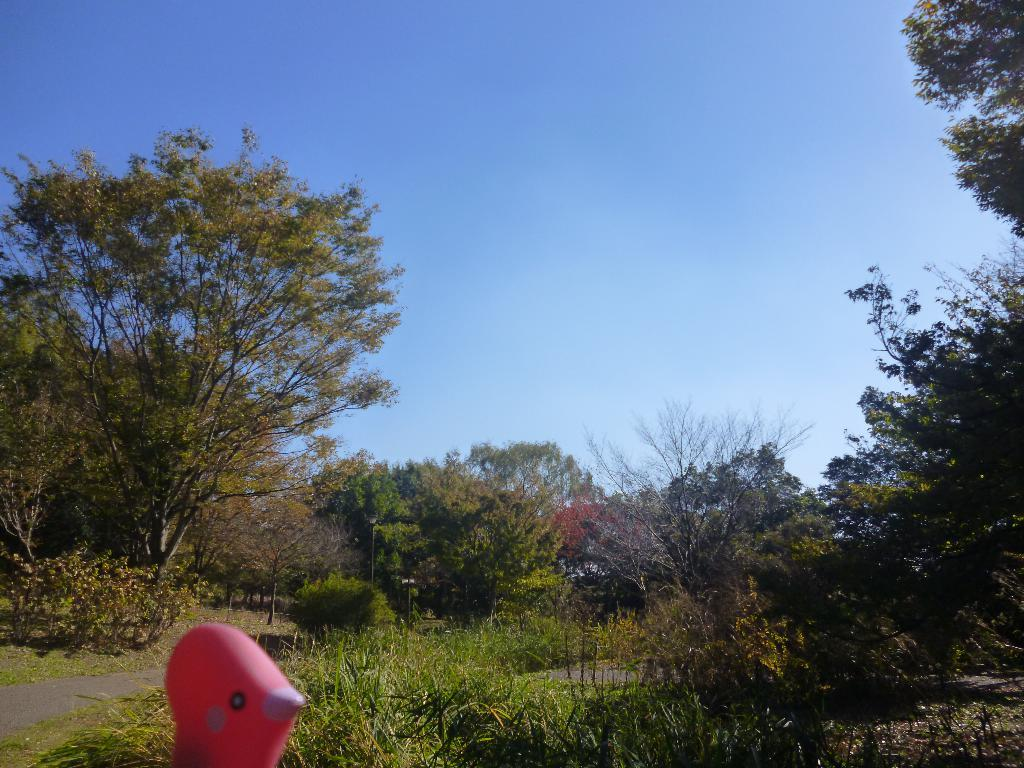What object can be seen in the image? There is a toy in the image. What is the color of the toy? The toy is pink in color. What can be seen in the background of the image? There are trees in the background of the image. What is the color of the trees? The trees are green in color. What color is the sky in the image? The sky is blue in color. What type of crate is being used to transport the toy in the image? There is no crate present in the image; the toy is not being transported. 